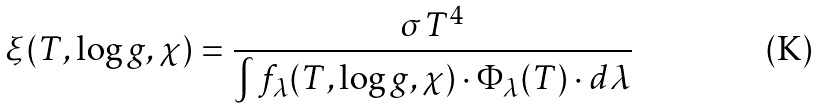Convert formula to latex. <formula><loc_0><loc_0><loc_500><loc_500>\xi ( T , \log g , \chi ) = \frac { \sigma T ^ { 4 } } { \int f _ { \lambda } ( T , \log g , \chi ) \cdot \Phi _ { \lambda } ( T ) \cdot d \lambda }</formula> 